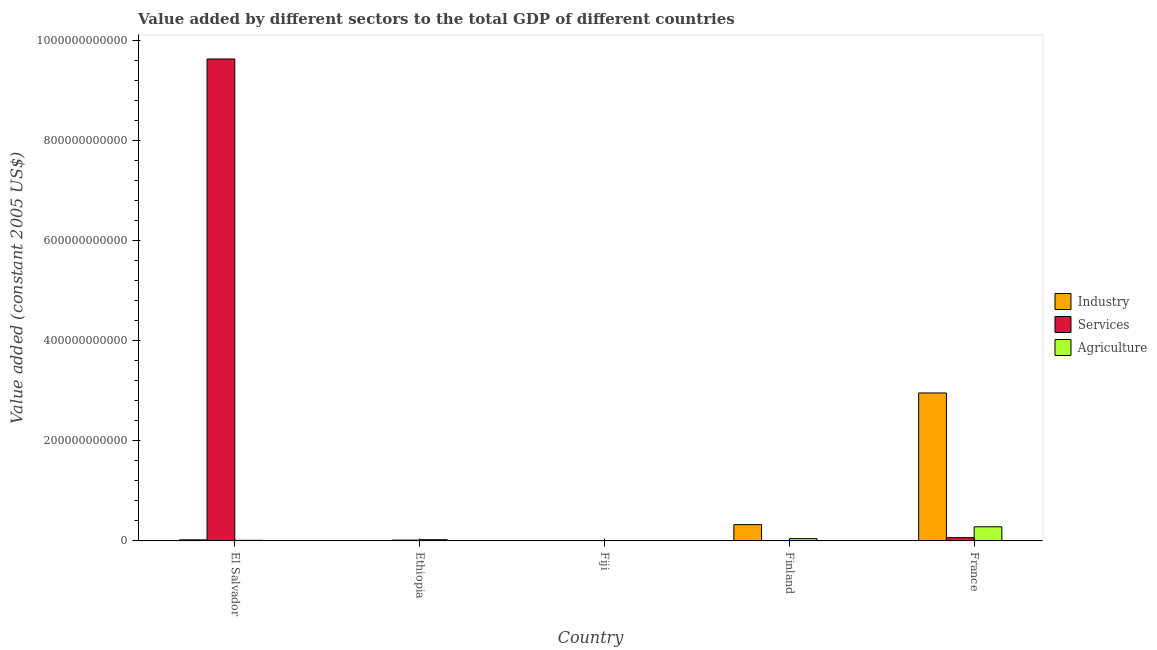Are the number of bars per tick equal to the number of legend labels?
Your answer should be compact. Yes. Are the number of bars on each tick of the X-axis equal?
Your answer should be compact. Yes. How many bars are there on the 2nd tick from the left?
Keep it short and to the point. 3. How many bars are there on the 3rd tick from the right?
Provide a short and direct response. 3. What is the label of the 5th group of bars from the left?
Provide a succinct answer. France. What is the value added by industrial sector in France?
Provide a succinct answer. 2.96e+11. Across all countries, what is the maximum value added by industrial sector?
Offer a terse response. 2.96e+11. Across all countries, what is the minimum value added by agricultural sector?
Your answer should be very brief. 3.27e+08. In which country was the value added by agricultural sector minimum?
Provide a short and direct response. Fiji. What is the total value added by agricultural sector in the graph?
Provide a short and direct response. 3.73e+1. What is the difference between the value added by agricultural sector in Finland and that in France?
Your answer should be compact. -2.37e+1. What is the difference between the value added by industrial sector in Fiji and the value added by services in Finland?
Offer a terse response. 9.34e+07. What is the average value added by services per country?
Your answer should be compact. 1.94e+11. What is the difference between the value added by industrial sector and value added by services in Finland?
Give a very brief answer. 3.24e+1. In how many countries, is the value added by agricultural sector greater than 520000000000 US$?
Your answer should be compact. 0. What is the ratio of the value added by agricultural sector in Ethiopia to that in France?
Ensure brevity in your answer.  0.09. Is the difference between the value added by industrial sector in Fiji and France greater than the difference between the value added by services in Fiji and France?
Your answer should be very brief. No. What is the difference between the highest and the second highest value added by agricultural sector?
Your answer should be compact. 2.37e+1. What is the difference between the highest and the lowest value added by services?
Give a very brief answer. 9.63e+11. In how many countries, is the value added by industrial sector greater than the average value added by industrial sector taken over all countries?
Provide a succinct answer. 1. What does the 1st bar from the left in El Salvador represents?
Offer a very short reply. Industry. What does the 1st bar from the right in El Salvador represents?
Ensure brevity in your answer.  Agriculture. Are all the bars in the graph horizontal?
Make the answer very short. No. How many countries are there in the graph?
Provide a succinct answer. 5. What is the difference between two consecutive major ticks on the Y-axis?
Your response must be concise. 2.00e+11. Does the graph contain grids?
Provide a succinct answer. No. Where does the legend appear in the graph?
Your response must be concise. Center right. What is the title of the graph?
Make the answer very short. Value added by different sectors to the total GDP of different countries. What is the label or title of the X-axis?
Offer a very short reply. Country. What is the label or title of the Y-axis?
Your answer should be very brief. Value added (constant 2005 US$). What is the Value added (constant 2005 US$) in Industry in El Salvador?
Provide a succinct answer. 2.27e+09. What is the Value added (constant 2005 US$) of Services in El Salvador?
Keep it short and to the point. 9.63e+11. What is the Value added (constant 2005 US$) of Agriculture in El Salvador?
Provide a succinct answer. 1.31e+09. What is the Value added (constant 2005 US$) in Industry in Ethiopia?
Your answer should be compact. 8.51e+08. What is the Value added (constant 2005 US$) in Services in Ethiopia?
Provide a succinct answer. 1.73e+09. What is the Value added (constant 2005 US$) of Agriculture in Ethiopia?
Ensure brevity in your answer.  2.60e+09. What is the Value added (constant 2005 US$) in Industry in Fiji?
Keep it short and to the point. 2.96e+08. What is the Value added (constant 2005 US$) in Services in Fiji?
Provide a short and direct response. 1.66e+08. What is the Value added (constant 2005 US$) of Agriculture in Fiji?
Your response must be concise. 3.27e+08. What is the Value added (constant 2005 US$) in Industry in Finland?
Provide a succinct answer. 3.26e+1. What is the Value added (constant 2005 US$) of Services in Finland?
Offer a very short reply. 2.02e+08. What is the Value added (constant 2005 US$) of Agriculture in Finland?
Offer a very short reply. 4.69e+09. What is the Value added (constant 2005 US$) of Industry in France?
Give a very brief answer. 2.96e+11. What is the Value added (constant 2005 US$) of Services in France?
Make the answer very short. 6.68e+09. What is the Value added (constant 2005 US$) in Agriculture in France?
Offer a terse response. 2.83e+1. Across all countries, what is the maximum Value added (constant 2005 US$) in Industry?
Keep it short and to the point. 2.96e+11. Across all countries, what is the maximum Value added (constant 2005 US$) in Services?
Give a very brief answer. 9.63e+11. Across all countries, what is the maximum Value added (constant 2005 US$) of Agriculture?
Offer a very short reply. 2.83e+1. Across all countries, what is the minimum Value added (constant 2005 US$) in Industry?
Your answer should be very brief. 2.96e+08. Across all countries, what is the minimum Value added (constant 2005 US$) of Services?
Provide a succinct answer. 1.66e+08. Across all countries, what is the minimum Value added (constant 2005 US$) of Agriculture?
Offer a terse response. 3.27e+08. What is the total Value added (constant 2005 US$) in Industry in the graph?
Ensure brevity in your answer.  3.32e+11. What is the total Value added (constant 2005 US$) of Services in the graph?
Provide a succinct answer. 9.71e+11. What is the total Value added (constant 2005 US$) of Agriculture in the graph?
Your response must be concise. 3.73e+1. What is the difference between the Value added (constant 2005 US$) of Industry in El Salvador and that in Ethiopia?
Offer a very short reply. 1.42e+09. What is the difference between the Value added (constant 2005 US$) of Services in El Salvador and that in Ethiopia?
Make the answer very short. 9.61e+11. What is the difference between the Value added (constant 2005 US$) in Agriculture in El Salvador and that in Ethiopia?
Your answer should be very brief. -1.28e+09. What is the difference between the Value added (constant 2005 US$) in Industry in El Salvador and that in Fiji?
Give a very brief answer. 1.98e+09. What is the difference between the Value added (constant 2005 US$) in Services in El Salvador and that in Fiji?
Your answer should be very brief. 9.63e+11. What is the difference between the Value added (constant 2005 US$) in Agriculture in El Salvador and that in Fiji?
Offer a very short reply. 9.88e+08. What is the difference between the Value added (constant 2005 US$) in Industry in El Salvador and that in Finland?
Your answer should be very brief. -3.04e+1. What is the difference between the Value added (constant 2005 US$) in Services in El Salvador and that in Finland?
Ensure brevity in your answer.  9.62e+11. What is the difference between the Value added (constant 2005 US$) in Agriculture in El Salvador and that in Finland?
Your answer should be compact. -3.38e+09. What is the difference between the Value added (constant 2005 US$) of Industry in El Salvador and that in France?
Your answer should be compact. -2.93e+11. What is the difference between the Value added (constant 2005 US$) in Services in El Salvador and that in France?
Your response must be concise. 9.56e+11. What is the difference between the Value added (constant 2005 US$) in Agriculture in El Salvador and that in France?
Give a very brief answer. -2.70e+1. What is the difference between the Value added (constant 2005 US$) of Industry in Ethiopia and that in Fiji?
Ensure brevity in your answer.  5.56e+08. What is the difference between the Value added (constant 2005 US$) in Services in Ethiopia and that in Fiji?
Your response must be concise. 1.57e+09. What is the difference between the Value added (constant 2005 US$) in Agriculture in Ethiopia and that in Fiji?
Ensure brevity in your answer.  2.27e+09. What is the difference between the Value added (constant 2005 US$) of Industry in Ethiopia and that in Finland?
Your response must be concise. -3.18e+1. What is the difference between the Value added (constant 2005 US$) of Services in Ethiopia and that in Finland?
Your answer should be compact. 1.53e+09. What is the difference between the Value added (constant 2005 US$) in Agriculture in Ethiopia and that in Finland?
Your answer should be very brief. -2.09e+09. What is the difference between the Value added (constant 2005 US$) of Industry in Ethiopia and that in France?
Offer a terse response. -2.95e+11. What is the difference between the Value added (constant 2005 US$) of Services in Ethiopia and that in France?
Offer a terse response. -4.94e+09. What is the difference between the Value added (constant 2005 US$) in Agriculture in Ethiopia and that in France?
Your answer should be compact. -2.57e+1. What is the difference between the Value added (constant 2005 US$) of Industry in Fiji and that in Finland?
Offer a very short reply. -3.23e+1. What is the difference between the Value added (constant 2005 US$) in Services in Fiji and that in Finland?
Give a very brief answer. -3.66e+07. What is the difference between the Value added (constant 2005 US$) of Agriculture in Fiji and that in Finland?
Your answer should be compact. -4.37e+09. What is the difference between the Value added (constant 2005 US$) in Industry in Fiji and that in France?
Your answer should be very brief. -2.95e+11. What is the difference between the Value added (constant 2005 US$) in Services in Fiji and that in France?
Make the answer very short. -6.51e+09. What is the difference between the Value added (constant 2005 US$) of Agriculture in Fiji and that in France?
Ensure brevity in your answer.  -2.80e+1. What is the difference between the Value added (constant 2005 US$) in Industry in Finland and that in France?
Give a very brief answer. -2.63e+11. What is the difference between the Value added (constant 2005 US$) in Services in Finland and that in France?
Your response must be concise. -6.47e+09. What is the difference between the Value added (constant 2005 US$) of Agriculture in Finland and that in France?
Offer a very short reply. -2.37e+1. What is the difference between the Value added (constant 2005 US$) of Industry in El Salvador and the Value added (constant 2005 US$) of Services in Ethiopia?
Keep it short and to the point. 5.39e+08. What is the difference between the Value added (constant 2005 US$) of Industry in El Salvador and the Value added (constant 2005 US$) of Agriculture in Ethiopia?
Provide a short and direct response. -3.27e+08. What is the difference between the Value added (constant 2005 US$) of Services in El Salvador and the Value added (constant 2005 US$) of Agriculture in Ethiopia?
Make the answer very short. 9.60e+11. What is the difference between the Value added (constant 2005 US$) of Industry in El Salvador and the Value added (constant 2005 US$) of Services in Fiji?
Give a very brief answer. 2.11e+09. What is the difference between the Value added (constant 2005 US$) in Industry in El Salvador and the Value added (constant 2005 US$) in Agriculture in Fiji?
Ensure brevity in your answer.  1.94e+09. What is the difference between the Value added (constant 2005 US$) of Services in El Salvador and the Value added (constant 2005 US$) of Agriculture in Fiji?
Give a very brief answer. 9.62e+11. What is the difference between the Value added (constant 2005 US$) of Industry in El Salvador and the Value added (constant 2005 US$) of Services in Finland?
Ensure brevity in your answer.  2.07e+09. What is the difference between the Value added (constant 2005 US$) of Industry in El Salvador and the Value added (constant 2005 US$) of Agriculture in Finland?
Provide a succinct answer. -2.42e+09. What is the difference between the Value added (constant 2005 US$) in Services in El Salvador and the Value added (constant 2005 US$) in Agriculture in Finland?
Your response must be concise. 9.58e+11. What is the difference between the Value added (constant 2005 US$) of Industry in El Salvador and the Value added (constant 2005 US$) of Services in France?
Provide a succinct answer. -4.40e+09. What is the difference between the Value added (constant 2005 US$) of Industry in El Salvador and the Value added (constant 2005 US$) of Agriculture in France?
Provide a short and direct response. -2.61e+1. What is the difference between the Value added (constant 2005 US$) of Services in El Salvador and the Value added (constant 2005 US$) of Agriculture in France?
Make the answer very short. 9.34e+11. What is the difference between the Value added (constant 2005 US$) of Industry in Ethiopia and the Value added (constant 2005 US$) of Services in Fiji?
Your answer should be very brief. 6.86e+08. What is the difference between the Value added (constant 2005 US$) in Industry in Ethiopia and the Value added (constant 2005 US$) in Agriculture in Fiji?
Your answer should be very brief. 5.25e+08. What is the difference between the Value added (constant 2005 US$) of Services in Ethiopia and the Value added (constant 2005 US$) of Agriculture in Fiji?
Ensure brevity in your answer.  1.41e+09. What is the difference between the Value added (constant 2005 US$) of Industry in Ethiopia and the Value added (constant 2005 US$) of Services in Finland?
Your response must be concise. 6.49e+08. What is the difference between the Value added (constant 2005 US$) of Industry in Ethiopia and the Value added (constant 2005 US$) of Agriculture in Finland?
Ensure brevity in your answer.  -3.84e+09. What is the difference between the Value added (constant 2005 US$) in Services in Ethiopia and the Value added (constant 2005 US$) in Agriculture in Finland?
Offer a very short reply. -2.96e+09. What is the difference between the Value added (constant 2005 US$) in Industry in Ethiopia and the Value added (constant 2005 US$) in Services in France?
Ensure brevity in your answer.  -5.82e+09. What is the difference between the Value added (constant 2005 US$) in Industry in Ethiopia and the Value added (constant 2005 US$) in Agriculture in France?
Your answer should be compact. -2.75e+1. What is the difference between the Value added (constant 2005 US$) in Services in Ethiopia and the Value added (constant 2005 US$) in Agriculture in France?
Offer a terse response. -2.66e+1. What is the difference between the Value added (constant 2005 US$) of Industry in Fiji and the Value added (constant 2005 US$) of Services in Finland?
Keep it short and to the point. 9.34e+07. What is the difference between the Value added (constant 2005 US$) in Industry in Fiji and the Value added (constant 2005 US$) in Agriculture in Finland?
Make the answer very short. -4.40e+09. What is the difference between the Value added (constant 2005 US$) of Services in Fiji and the Value added (constant 2005 US$) of Agriculture in Finland?
Provide a short and direct response. -4.53e+09. What is the difference between the Value added (constant 2005 US$) of Industry in Fiji and the Value added (constant 2005 US$) of Services in France?
Keep it short and to the point. -6.38e+09. What is the difference between the Value added (constant 2005 US$) of Industry in Fiji and the Value added (constant 2005 US$) of Agriculture in France?
Provide a succinct answer. -2.81e+1. What is the difference between the Value added (constant 2005 US$) of Services in Fiji and the Value added (constant 2005 US$) of Agriculture in France?
Offer a terse response. -2.82e+1. What is the difference between the Value added (constant 2005 US$) in Industry in Finland and the Value added (constant 2005 US$) in Services in France?
Your answer should be compact. 2.60e+1. What is the difference between the Value added (constant 2005 US$) in Industry in Finland and the Value added (constant 2005 US$) in Agriculture in France?
Keep it short and to the point. 4.29e+09. What is the difference between the Value added (constant 2005 US$) of Services in Finland and the Value added (constant 2005 US$) of Agriculture in France?
Offer a terse response. -2.81e+1. What is the average Value added (constant 2005 US$) in Industry per country?
Provide a succinct answer. 6.63e+1. What is the average Value added (constant 2005 US$) in Services per country?
Offer a very short reply. 1.94e+11. What is the average Value added (constant 2005 US$) of Agriculture per country?
Your response must be concise. 7.46e+09. What is the difference between the Value added (constant 2005 US$) in Industry and Value added (constant 2005 US$) in Services in El Salvador?
Your answer should be very brief. -9.60e+11. What is the difference between the Value added (constant 2005 US$) of Industry and Value added (constant 2005 US$) of Agriculture in El Salvador?
Provide a succinct answer. 9.56e+08. What is the difference between the Value added (constant 2005 US$) of Services and Value added (constant 2005 US$) of Agriculture in El Salvador?
Offer a terse response. 9.61e+11. What is the difference between the Value added (constant 2005 US$) in Industry and Value added (constant 2005 US$) in Services in Ethiopia?
Your response must be concise. -8.81e+08. What is the difference between the Value added (constant 2005 US$) in Industry and Value added (constant 2005 US$) in Agriculture in Ethiopia?
Make the answer very short. -1.75e+09. What is the difference between the Value added (constant 2005 US$) in Services and Value added (constant 2005 US$) in Agriculture in Ethiopia?
Keep it short and to the point. -8.66e+08. What is the difference between the Value added (constant 2005 US$) in Industry and Value added (constant 2005 US$) in Services in Fiji?
Provide a short and direct response. 1.30e+08. What is the difference between the Value added (constant 2005 US$) of Industry and Value added (constant 2005 US$) of Agriculture in Fiji?
Your response must be concise. -3.11e+07. What is the difference between the Value added (constant 2005 US$) in Services and Value added (constant 2005 US$) in Agriculture in Fiji?
Keep it short and to the point. -1.61e+08. What is the difference between the Value added (constant 2005 US$) in Industry and Value added (constant 2005 US$) in Services in Finland?
Offer a very short reply. 3.24e+1. What is the difference between the Value added (constant 2005 US$) of Industry and Value added (constant 2005 US$) of Agriculture in Finland?
Provide a short and direct response. 2.79e+1. What is the difference between the Value added (constant 2005 US$) of Services and Value added (constant 2005 US$) of Agriculture in Finland?
Your answer should be very brief. -4.49e+09. What is the difference between the Value added (constant 2005 US$) of Industry and Value added (constant 2005 US$) of Services in France?
Keep it short and to the point. 2.89e+11. What is the difference between the Value added (constant 2005 US$) in Industry and Value added (constant 2005 US$) in Agriculture in France?
Your answer should be compact. 2.67e+11. What is the difference between the Value added (constant 2005 US$) of Services and Value added (constant 2005 US$) of Agriculture in France?
Offer a very short reply. -2.17e+1. What is the ratio of the Value added (constant 2005 US$) in Industry in El Salvador to that in Ethiopia?
Make the answer very short. 2.67. What is the ratio of the Value added (constant 2005 US$) in Services in El Salvador to that in Ethiopia?
Provide a short and direct response. 555.76. What is the ratio of the Value added (constant 2005 US$) of Agriculture in El Salvador to that in Ethiopia?
Ensure brevity in your answer.  0.51. What is the ratio of the Value added (constant 2005 US$) in Industry in El Salvador to that in Fiji?
Give a very brief answer. 7.68. What is the ratio of the Value added (constant 2005 US$) in Services in El Salvador to that in Fiji?
Provide a succinct answer. 5804.01. What is the ratio of the Value added (constant 2005 US$) in Agriculture in El Salvador to that in Fiji?
Provide a short and direct response. 4.02. What is the ratio of the Value added (constant 2005 US$) in Industry in El Salvador to that in Finland?
Offer a very short reply. 0.07. What is the ratio of the Value added (constant 2005 US$) in Services in El Salvador to that in Finland?
Provide a succinct answer. 4754.84. What is the ratio of the Value added (constant 2005 US$) in Agriculture in El Salvador to that in Finland?
Provide a short and direct response. 0.28. What is the ratio of the Value added (constant 2005 US$) in Industry in El Salvador to that in France?
Your answer should be very brief. 0.01. What is the ratio of the Value added (constant 2005 US$) of Services in El Salvador to that in France?
Make the answer very short. 144.21. What is the ratio of the Value added (constant 2005 US$) in Agriculture in El Salvador to that in France?
Provide a short and direct response. 0.05. What is the ratio of the Value added (constant 2005 US$) in Industry in Ethiopia to that in Fiji?
Your answer should be very brief. 2.88. What is the ratio of the Value added (constant 2005 US$) of Services in Ethiopia to that in Fiji?
Ensure brevity in your answer.  10.44. What is the ratio of the Value added (constant 2005 US$) of Agriculture in Ethiopia to that in Fiji?
Provide a succinct answer. 7.95. What is the ratio of the Value added (constant 2005 US$) of Industry in Ethiopia to that in Finland?
Your answer should be compact. 0.03. What is the ratio of the Value added (constant 2005 US$) in Services in Ethiopia to that in Finland?
Offer a very short reply. 8.56. What is the ratio of the Value added (constant 2005 US$) of Agriculture in Ethiopia to that in Finland?
Make the answer very short. 0.55. What is the ratio of the Value added (constant 2005 US$) in Industry in Ethiopia to that in France?
Provide a short and direct response. 0. What is the ratio of the Value added (constant 2005 US$) of Services in Ethiopia to that in France?
Offer a terse response. 0.26. What is the ratio of the Value added (constant 2005 US$) in Agriculture in Ethiopia to that in France?
Provide a short and direct response. 0.09. What is the ratio of the Value added (constant 2005 US$) of Industry in Fiji to that in Finland?
Keep it short and to the point. 0.01. What is the ratio of the Value added (constant 2005 US$) of Services in Fiji to that in Finland?
Provide a short and direct response. 0.82. What is the ratio of the Value added (constant 2005 US$) in Agriculture in Fiji to that in Finland?
Offer a terse response. 0.07. What is the ratio of the Value added (constant 2005 US$) in Services in Fiji to that in France?
Make the answer very short. 0.02. What is the ratio of the Value added (constant 2005 US$) of Agriculture in Fiji to that in France?
Provide a succinct answer. 0.01. What is the ratio of the Value added (constant 2005 US$) in Industry in Finland to that in France?
Give a very brief answer. 0.11. What is the ratio of the Value added (constant 2005 US$) of Services in Finland to that in France?
Your answer should be very brief. 0.03. What is the ratio of the Value added (constant 2005 US$) of Agriculture in Finland to that in France?
Offer a very short reply. 0.17. What is the difference between the highest and the second highest Value added (constant 2005 US$) in Industry?
Provide a succinct answer. 2.63e+11. What is the difference between the highest and the second highest Value added (constant 2005 US$) in Services?
Make the answer very short. 9.56e+11. What is the difference between the highest and the second highest Value added (constant 2005 US$) in Agriculture?
Give a very brief answer. 2.37e+1. What is the difference between the highest and the lowest Value added (constant 2005 US$) of Industry?
Your answer should be compact. 2.95e+11. What is the difference between the highest and the lowest Value added (constant 2005 US$) of Services?
Your response must be concise. 9.63e+11. What is the difference between the highest and the lowest Value added (constant 2005 US$) in Agriculture?
Give a very brief answer. 2.80e+1. 